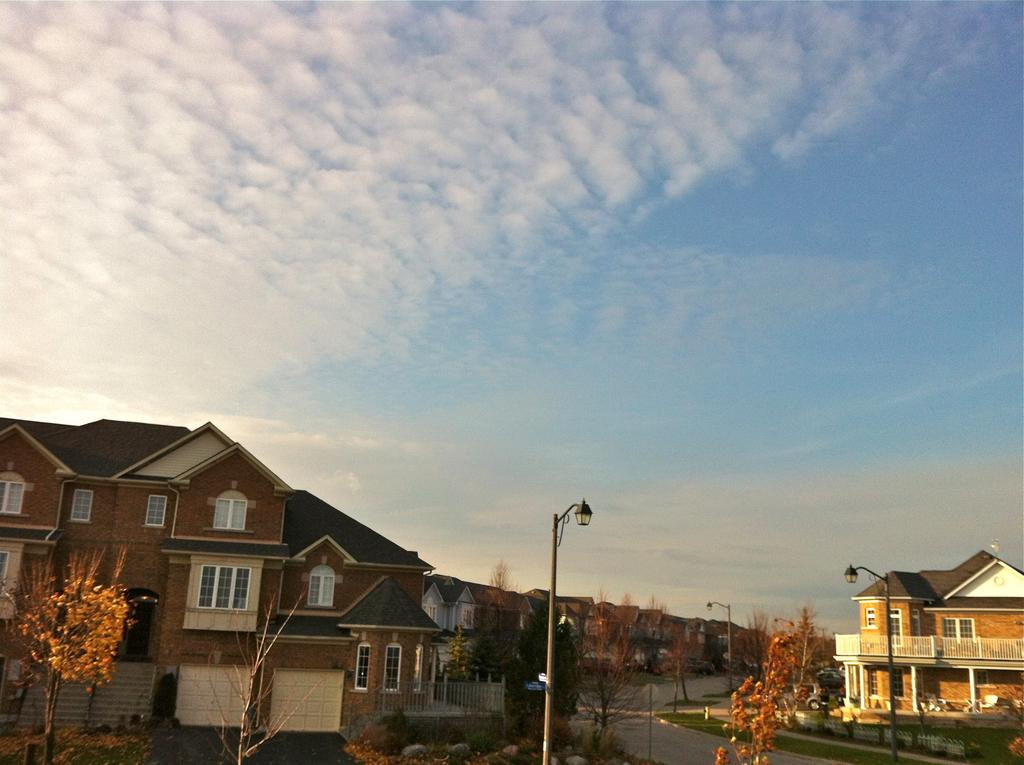What type of structures are visible in the image? There are houses in the image. What else can be seen in the image besides the houses? There are poles, a road, trees, and the sky visible in the image. How many ladybugs can be seen crawling on the houses in the image? There are no ladybugs present in the image; it only features houses, poles, a road, trees, and the sky. 